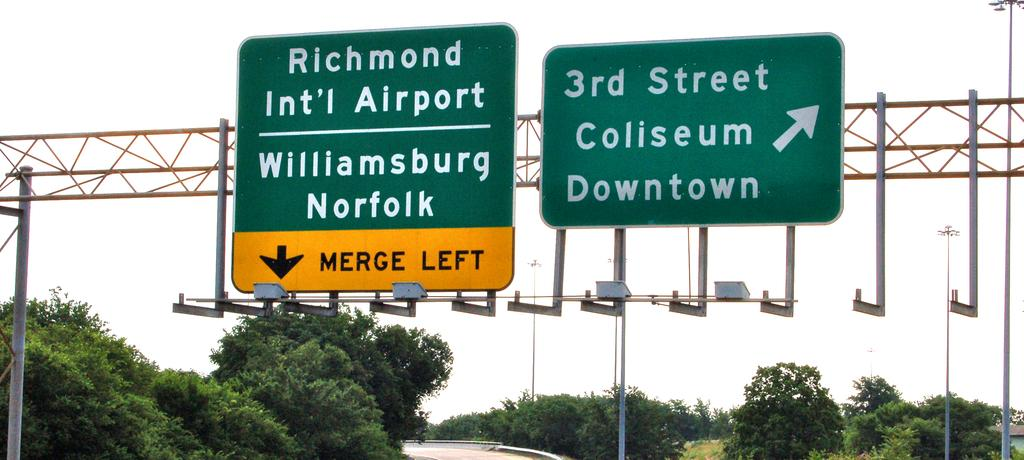Provide a one-sentence caption for the provided image. A merge left sign points to the Richmond International Airport. 